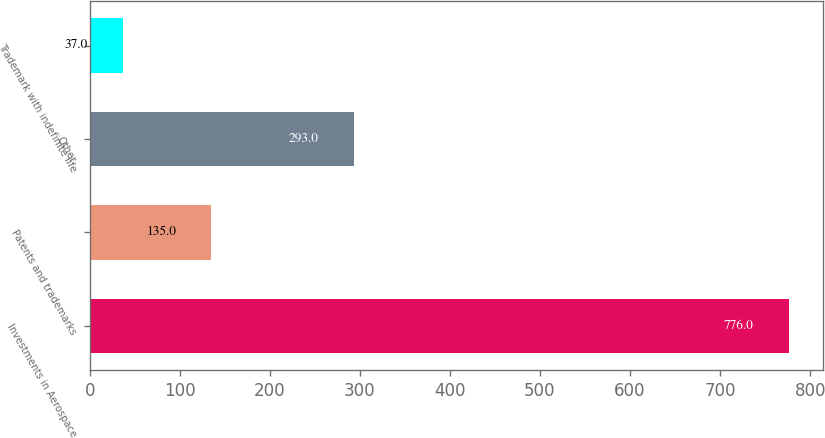Convert chart to OTSL. <chart><loc_0><loc_0><loc_500><loc_500><bar_chart><fcel>Investments in Aerospace<fcel>Patents and trademarks<fcel>Other<fcel>Trademark with indefinite life<nl><fcel>776<fcel>135<fcel>293<fcel>37<nl></chart> 